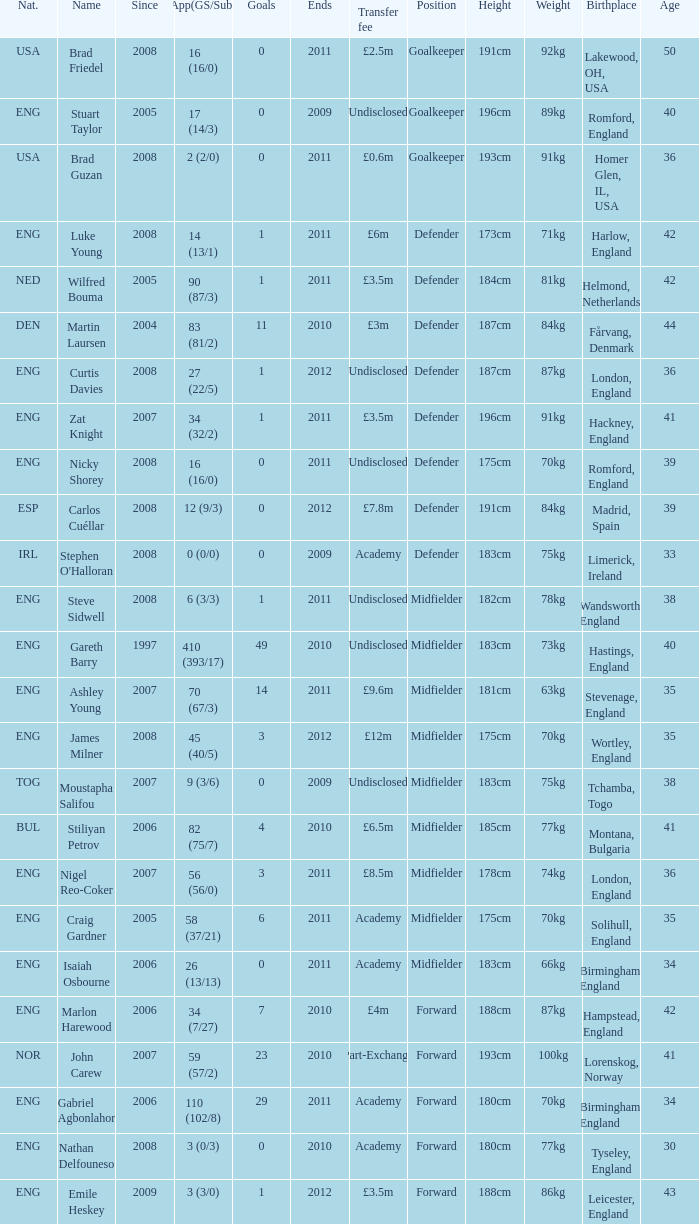What is the greatest goals for Curtis Davies if ends is greater than 2012? None. 